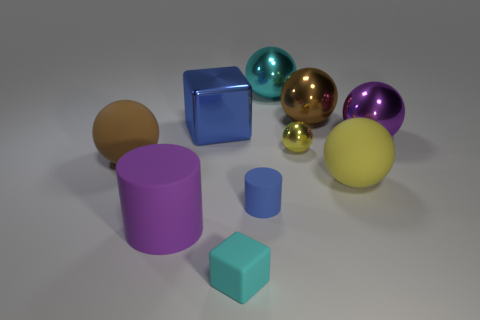Subtract all rubber balls. How many balls are left? 4 Subtract all brown balls. How many balls are left? 4 Subtract all gray blocks. How many yellow balls are left? 2 Subtract 1 balls. How many balls are left? 5 Subtract all blue balls. Subtract all brown cubes. How many balls are left? 6 Subtract all rubber cubes. Subtract all large brown objects. How many objects are left? 7 Add 3 tiny cylinders. How many tiny cylinders are left? 4 Add 8 small gray metallic cylinders. How many small gray metallic cylinders exist? 8 Subtract 0 gray cylinders. How many objects are left? 10 Subtract all blocks. How many objects are left? 8 